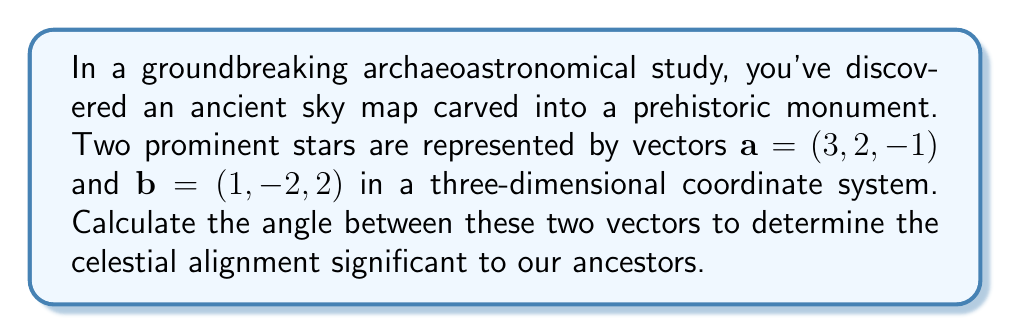What is the answer to this math problem? To find the angle between two vectors, we'll use the dot product formula:

$$\cos \theta = \frac{\mathbf{a} \cdot \mathbf{b}}{|\mathbf{a}||\mathbf{b}|}$$

Step 1: Calculate the dot product $\mathbf{a} \cdot \mathbf{b}$
$$\mathbf{a} \cdot \mathbf{b} = (3)(1) + (2)(-2) + (-1)(2) = 3 - 4 - 2 = -3$$

Step 2: Calculate the magnitudes of vectors $\mathbf{a}$ and $\mathbf{b}$
$$|\mathbf{a}| = \sqrt{3^2 + 2^2 + (-1)^2} = \sqrt{14}$$
$$|\mathbf{b}| = \sqrt{1^2 + (-2)^2 + 2^2} = 3$$

Step 3: Substitute into the formula
$$\cos \theta = \frac{-3}{\sqrt{14} \cdot 3}$$

Step 4: Simplify
$$\cos \theta = -\frac{1}{\sqrt{14}}$$

Step 5: Take the inverse cosine (arccos) of both sides
$$\theta = \arccos\left(-\frac{1}{\sqrt{14}}\right)$$

Step 6: Calculate the result (approximately)
$$\theta \approx 1.8235 \text{ radians} \approx 104.48°$$

This angle provides crucial information about the celestial alignment observed by our ancestors, potentially revealing insights into their astronomical knowledge and cultural practices.
Answer: $\arccos\left(-\frac{1}{\sqrt{14}}\right) \approx 104.48°$ 